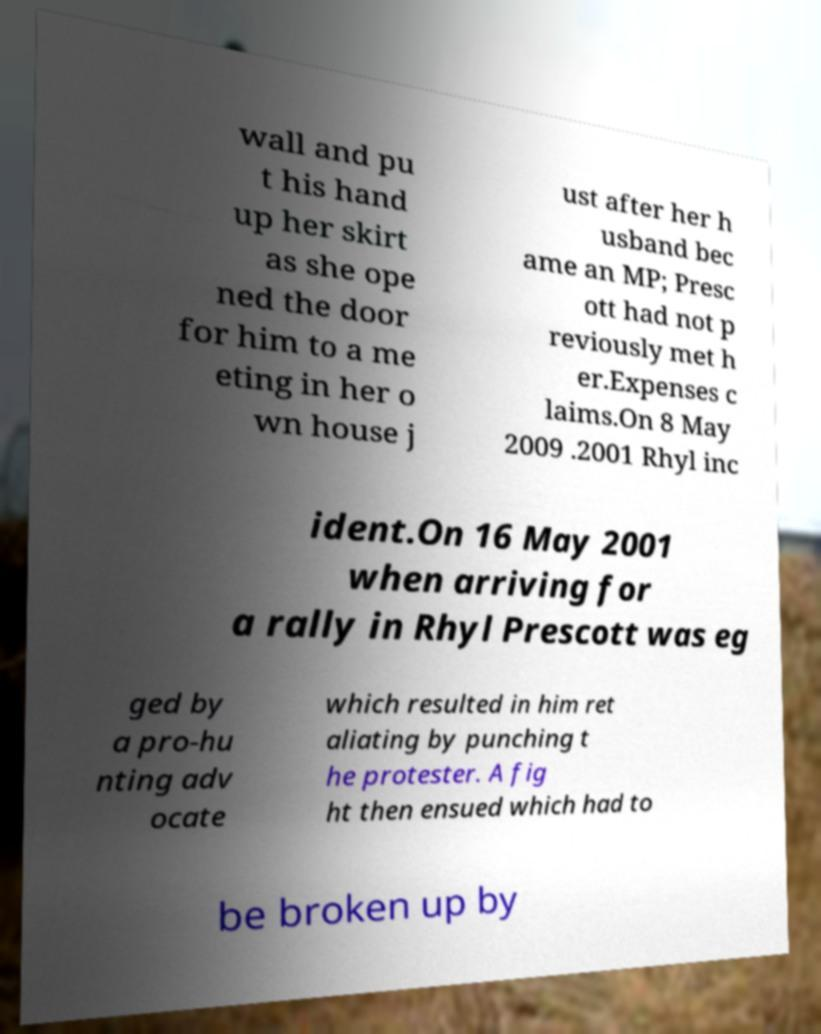What messages or text are displayed in this image? I need them in a readable, typed format. wall and pu t his hand up her skirt as she ope ned the door for him to a me eting in her o wn house j ust after her h usband bec ame an MP; Presc ott had not p reviously met h er.Expenses c laims.On 8 May 2009 .2001 Rhyl inc ident.On 16 May 2001 when arriving for a rally in Rhyl Prescott was eg ged by a pro-hu nting adv ocate which resulted in him ret aliating by punching t he protester. A fig ht then ensued which had to be broken up by 